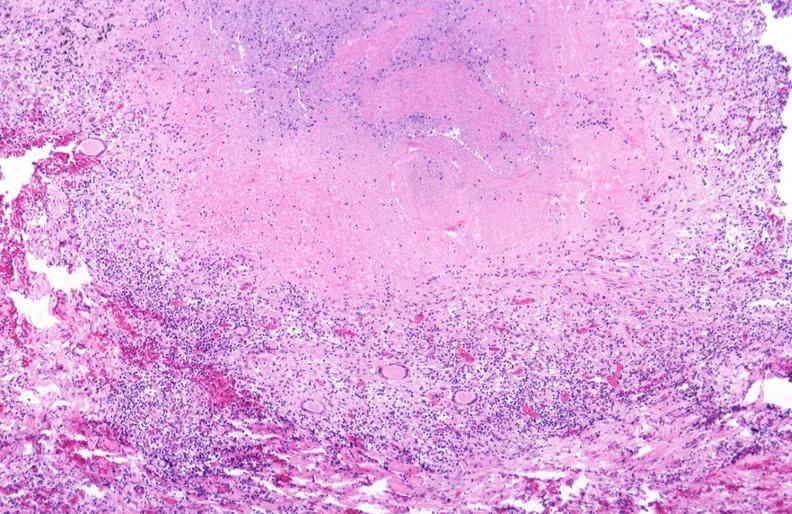s micrognathia triploid fetus present?
Answer the question using a single word or phrase. No 